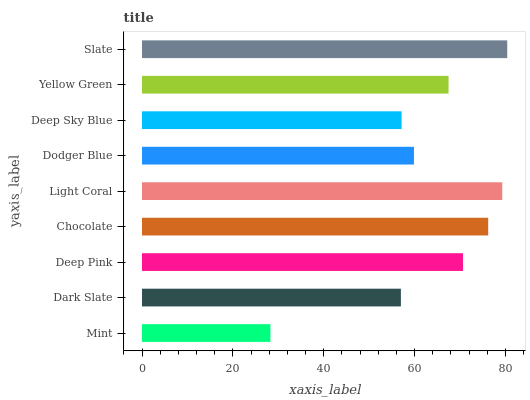Is Mint the minimum?
Answer yes or no. Yes. Is Slate the maximum?
Answer yes or no. Yes. Is Dark Slate the minimum?
Answer yes or no. No. Is Dark Slate the maximum?
Answer yes or no. No. Is Dark Slate greater than Mint?
Answer yes or no. Yes. Is Mint less than Dark Slate?
Answer yes or no. Yes. Is Mint greater than Dark Slate?
Answer yes or no. No. Is Dark Slate less than Mint?
Answer yes or no. No. Is Yellow Green the high median?
Answer yes or no. Yes. Is Yellow Green the low median?
Answer yes or no. Yes. Is Dodger Blue the high median?
Answer yes or no. No. Is Deep Sky Blue the low median?
Answer yes or no. No. 